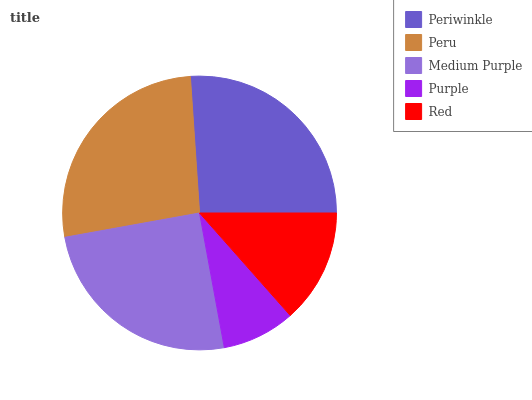Is Purple the minimum?
Answer yes or no. Yes. Is Peru the maximum?
Answer yes or no. Yes. Is Medium Purple the minimum?
Answer yes or no. No. Is Medium Purple the maximum?
Answer yes or no. No. Is Peru greater than Medium Purple?
Answer yes or no. Yes. Is Medium Purple less than Peru?
Answer yes or no. Yes. Is Medium Purple greater than Peru?
Answer yes or no. No. Is Peru less than Medium Purple?
Answer yes or no. No. Is Medium Purple the high median?
Answer yes or no. Yes. Is Medium Purple the low median?
Answer yes or no. Yes. Is Periwinkle the high median?
Answer yes or no. No. Is Periwinkle the low median?
Answer yes or no. No. 